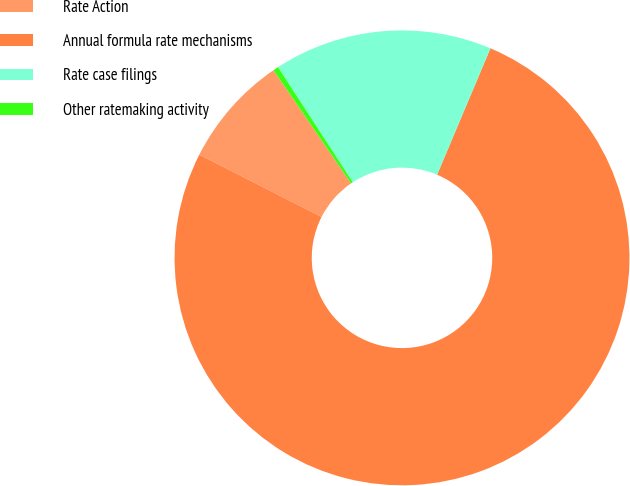Convert chart to OTSL. <chart><loc_0><loc_0><loc_500><loc_500><pie_chart><fcel>Rate Action<fcel>Annual formula rate mechanisms<fcel>Rate case filings<fcel>Other ratemaking activity<nl><fcel>7.95%<fcel>76.14%<fcel>15.53%<fcel>0.38%<nl></chart> 